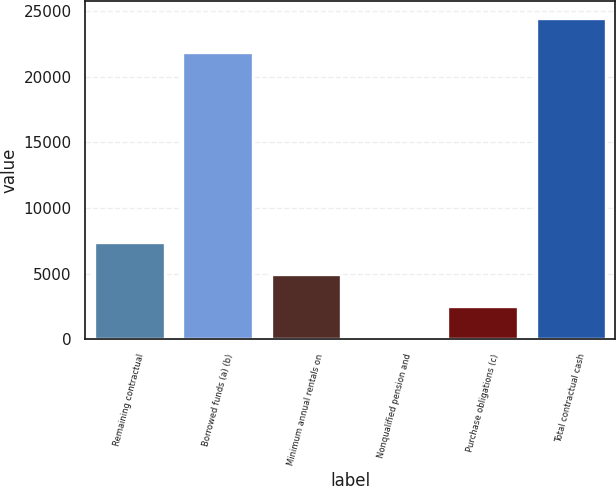<chart> <loc_0><loc_0><loc_500><loc_500><bar_chart><fcel>Remaining contractual<fcel>Borrowed funds (a) (b)<fcel>Minimum annual rentals on<fcel>Nonqualified pension and<fcel>Purchase obligations (c)<fcel>Total contractual cash<nl><fcel>7419.9<fcel>21888<fcel>4981.6<fcel>105<fcel>2543.3<fcel>24488<nl></chart> 